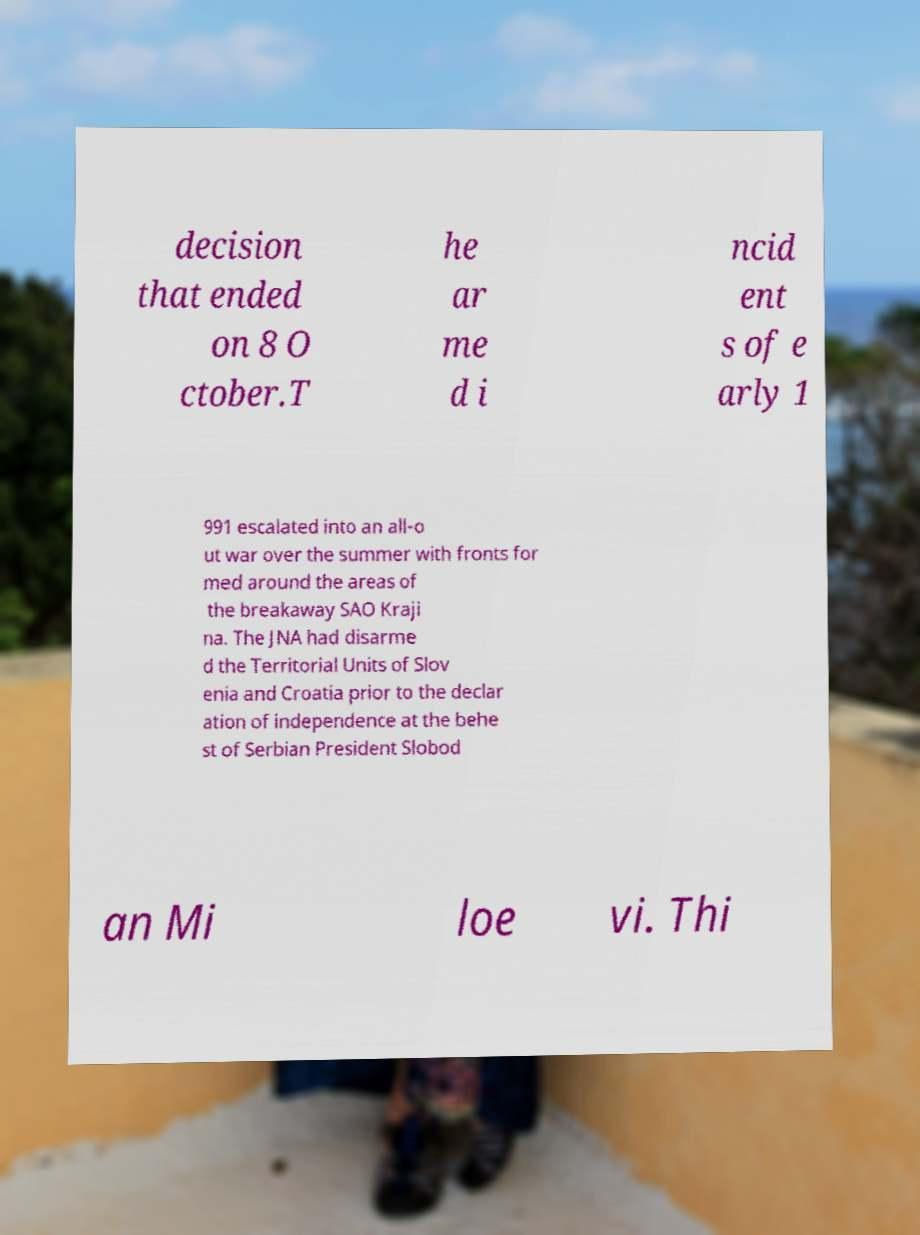Can you accurately transcribe the text from the provided image for me? decision that ended on 8 O ctober.T he ar me d i ncid ent s of e arly 1 991 escalated into an all-o ut war over the summer with fronts for med around the areas of the breakaway SAO Kraji na. The JNA had disarme d the Territorial Units of Slov enia and Croatia prior to the declar ation of independence at the behe st of Serbian President Slobod an Mi loe vi. Thi 